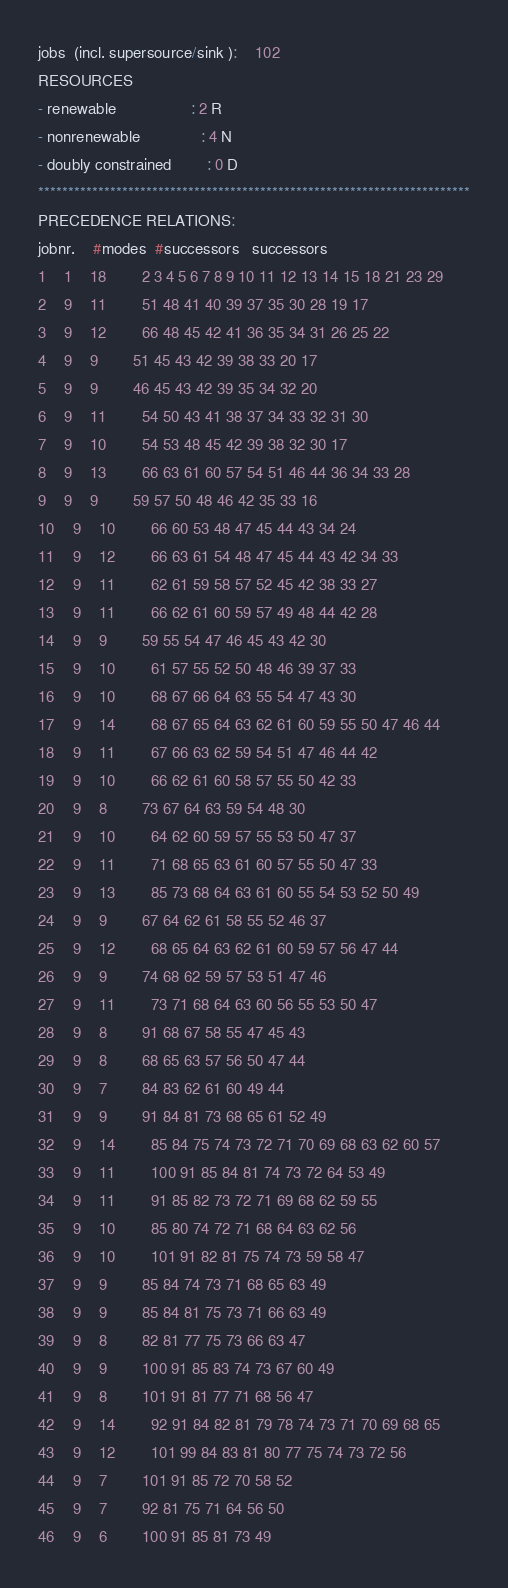<code> <loc_0><loc_0><loc_500><loc_500><_ObjectiveC_>jobs  (incl. supersource/sink ):	102
RESOURCES
- renewable                 : 2 R
- nonrenewable              : 4 N
- doubly constrained        : 0 D
************************************************************************
PRECEDENCE RELATIONS:
jobnr.    #modes  #successors   successors
1	1	18		2 3 4 5 6 7 8 9 10 11 12 13 14 15 18 21 23 29 
2	9	11		51 48 41 40 39 37 35 30 28 19 17 
3	9	12		66 48 45 42 41 36 35 34 31 26 25 22 
4	9	9		51 45 43 42 39 38 33 20 17 
5	9	9		46 45 43 42 39 35 34 32 20 
6	9	11		54 50 43 41 38 37 34 33 32 31 30 
7	9	10		54 53 48 45 42 39 38 32 30 17 
8	9	13		66 63 61 60 57 54 51 46 44 36 34 33 28 
9	9	9		59 57 50 48 46 42 35 33 16 
10	9	10		66 60 53 48 47 45 44 43 34 24 
11	9	12		66 63 61 54 48 47 45 44 43 42 34 33 
12	9	11		62 61 59 58 57 52 45 42 38 33 27 
13	9	11		66 62 61 60 59 57 49 48 44 42 28 
14	9	9		59 55 54 47 46 45 43 42 30 
15	9	10		61 57 55 52 50 48 46 39 37 33 
16	9	10		68 67 66 64 63 55 54 47 43 30 
17	9	14		68 67 65 64 63 62 61 60 59 55 50 47 46 44 
18	9	11		67 66 63 62 59 54 51 47 46 44 42 
19	9	10		66 62 61 60 58 57 55 50 42 33 
20	9	8		73 67 64 63 59 54 48 30 
21	9	10		64 62 60 59 57 55 53 50 47 37 
22	9	11		71 68 65 63 61 60 57 55 50 47 33 
23	9	13		85 73 68 64 63 61 60 55 54 53 52 50 49 
24	9	9		67 64 62 61 58 55 52 46 37 
25	9	12		68 65 64 63 62 61 60 59 57 56 47 44 
26	9	9		74 68 62 59 57 53 51 47 46 
27	9	11		73 71 68 64 63 60 56 55 53 50 47 
28	9	8		91 68 67 58 55 47 45 43 
29	9	8		68 65 63 57 56 50 47 44 
30	9	7		84 83 62 61 60 49 44 
31	9	9		91 84 81 73 68 65 61 52 49 
32	9	14		85 84 75 74 73 72 71 70 69 68 63 62 60 57 
33	9	11		100 91 85 84 81 74 73 72 64 53 49 
34	9	11		91 85 82 73 72 71 69 68 62 59 55 
35	9	10		85 80 74 72 71 68 64 63 62 56 
36	9	10		101 91 82 81 75 74 73 59 58 47 
37	9	9		85 84 74 73 71 68 65 63 49 
38	9	9		85 84 81 75 73 71 66 63 49 
39	9	8		82 81 77 75 73 66 63 47 
40	9	9		100 91 85 83 74 73 67 60 49 
41	9	8		101 91 81 77 71 68 56 47 
42	9	14		92 91 84 82 81 79 78 74 73 71 70 69 68 65 
43	9	12		101 99 84 83 81 80 77 75 74 73 72 56 
44	9	7		101 91 85 72 70 58 52 
45	9	7		92 81 75 71 64 56 50 
46	9	6		100 91 85 81 73 49 </code> 